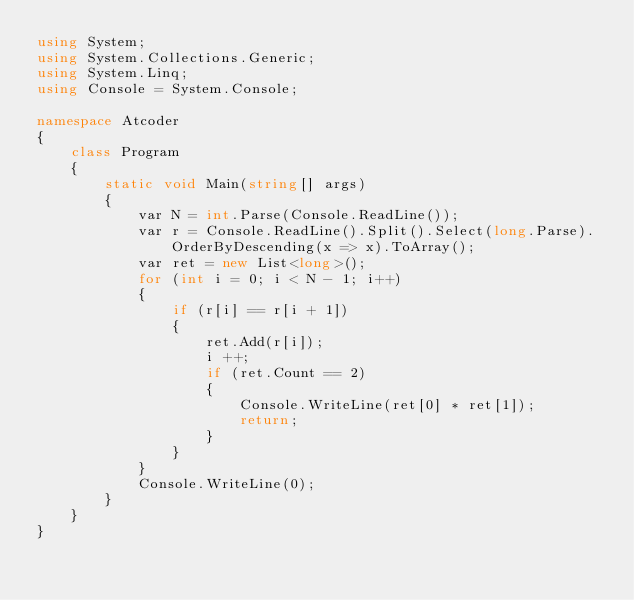<code> <loc_0><loc_0><loc_500><loc_500><_C#_>using System;
using System.Collections.Generic;
using System.Linq;
using Console = System.Console;

namespace Atcoder
{
    class Program
    {
        static void Main(string[] args)
        {
            var N = int.Parse(Console.ReadLine());
            var r = Console.ReadLine().Split().Select(long.Parse).OrderByDescending(x => x).ToArray();
            var ret = new List<long>();
            for (int i = 0; i < N - 1; i++)
            {
                if (r[i] == r[i + 1])
                {
                    ret.Add(r[i]);
                    i ++;
                    if (ret.Count == 2)
                    {
                        Console.WriteLine(ret[0] * ret[1]);
                        return;
                    }
                }
            }
            Console.WriteLine(0);
        }
    }
}</code> 